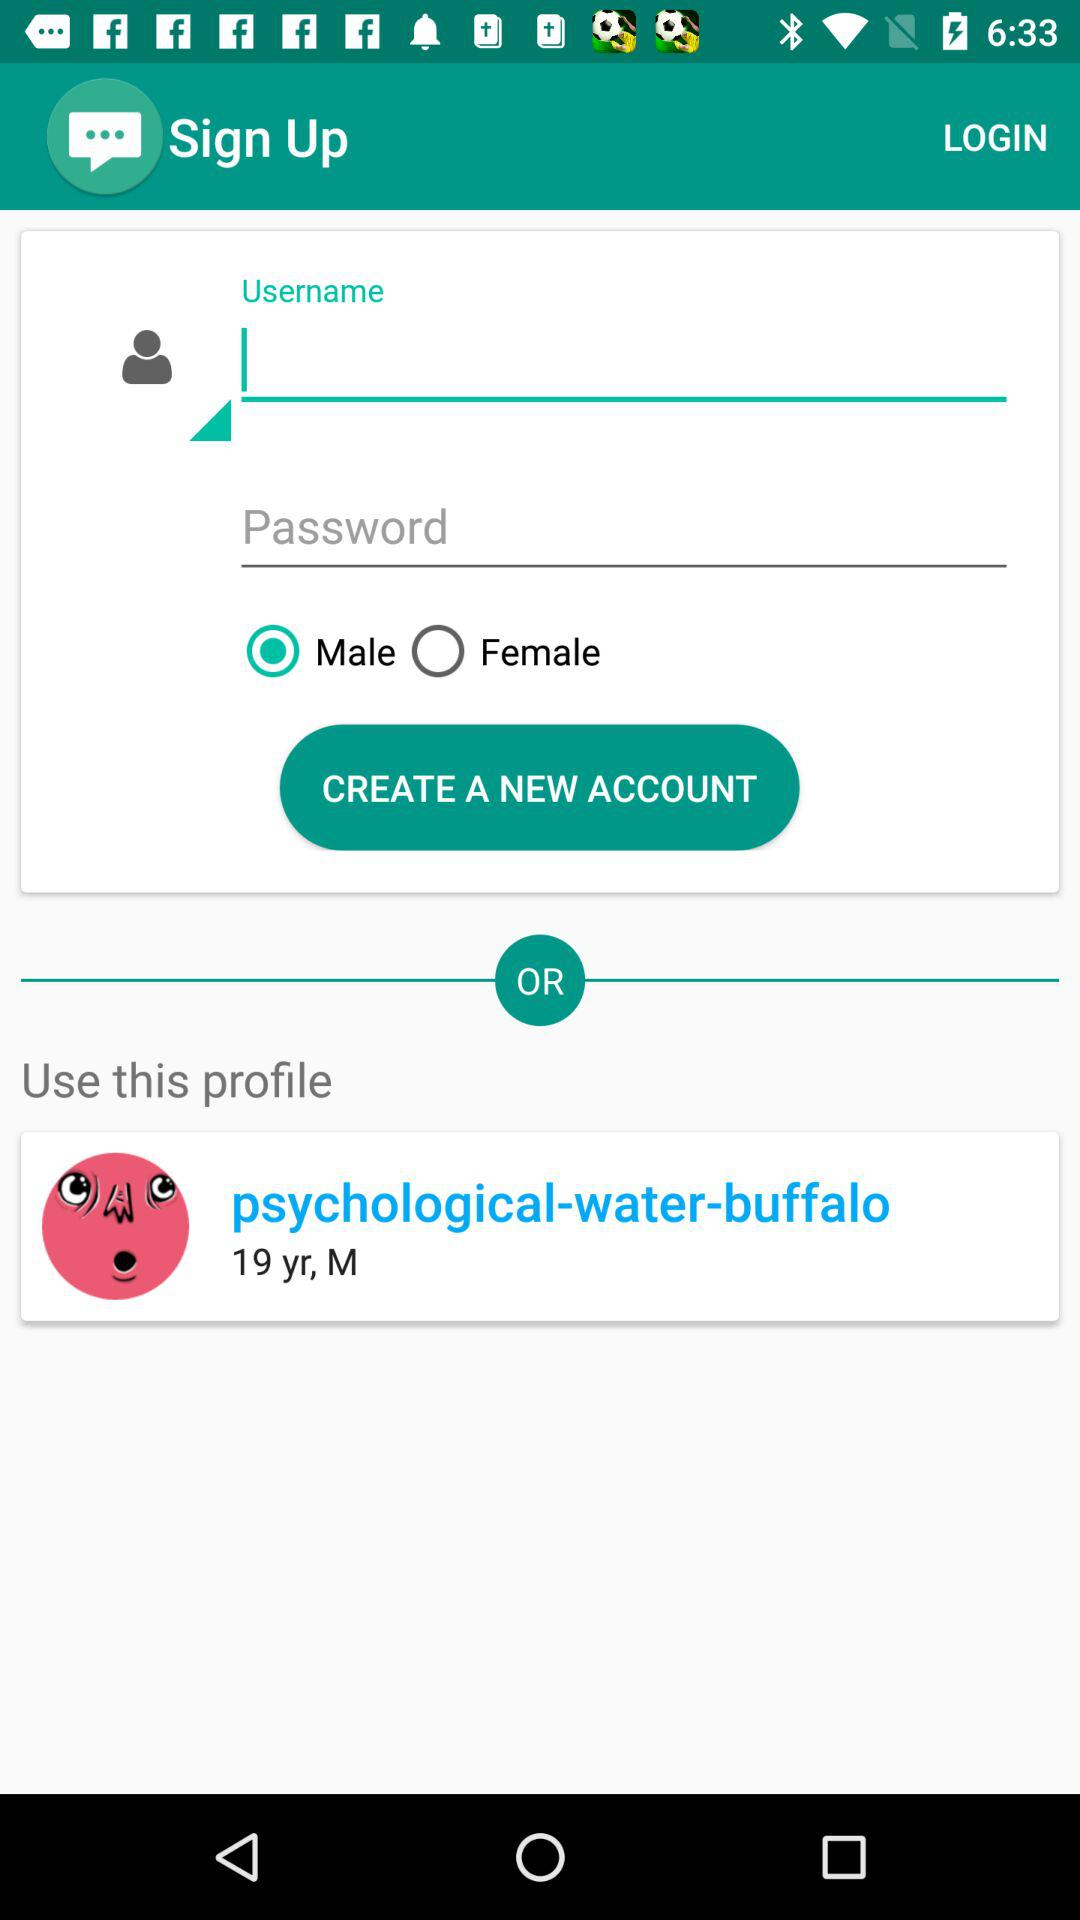Which is the selected option? The selected option is male. 